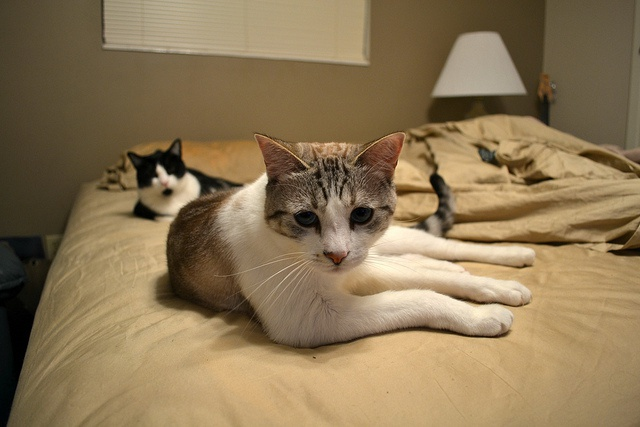Describe the objects in this image and their specific colors. I can see bed in black, tan, and olive tones, cat in black, gray, tan, and maroon tones, and cat in black, tan, olive, and gray tones in this image. 